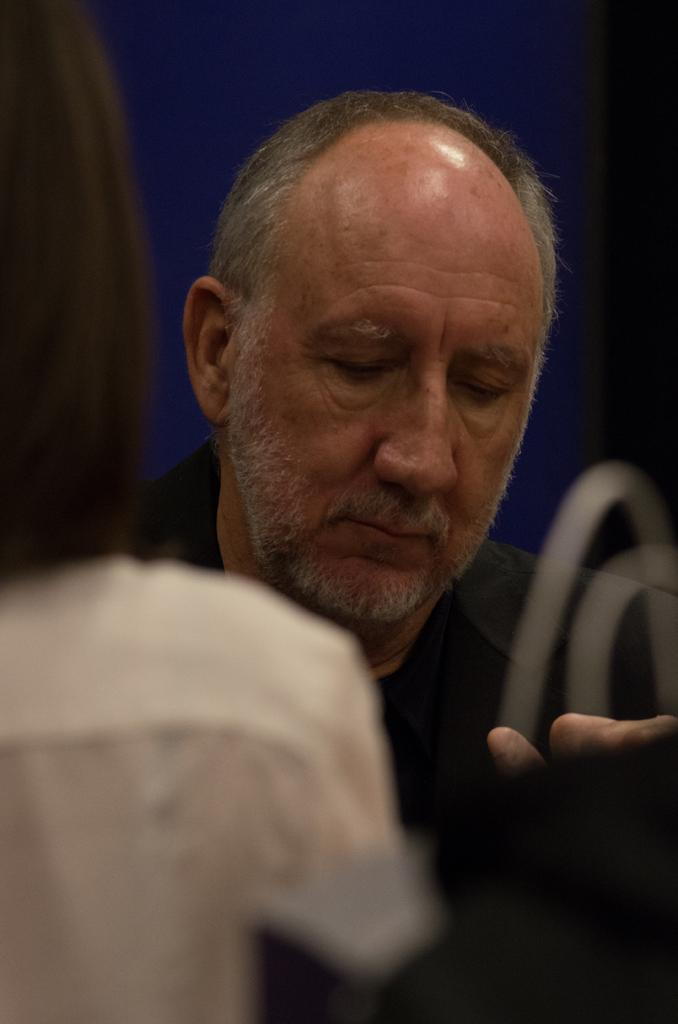What is the main subject of the image? There is a person's face in the image. What color is the background of the image? The background of the image is blue. Can you describe any other objects in the image besides the person's face? There is a white object in the image. What type of building can be seen in the background of the image? There is no building visible in the image; the background is blue. How many baskets are present in the image? There are no baskets present in the image. 